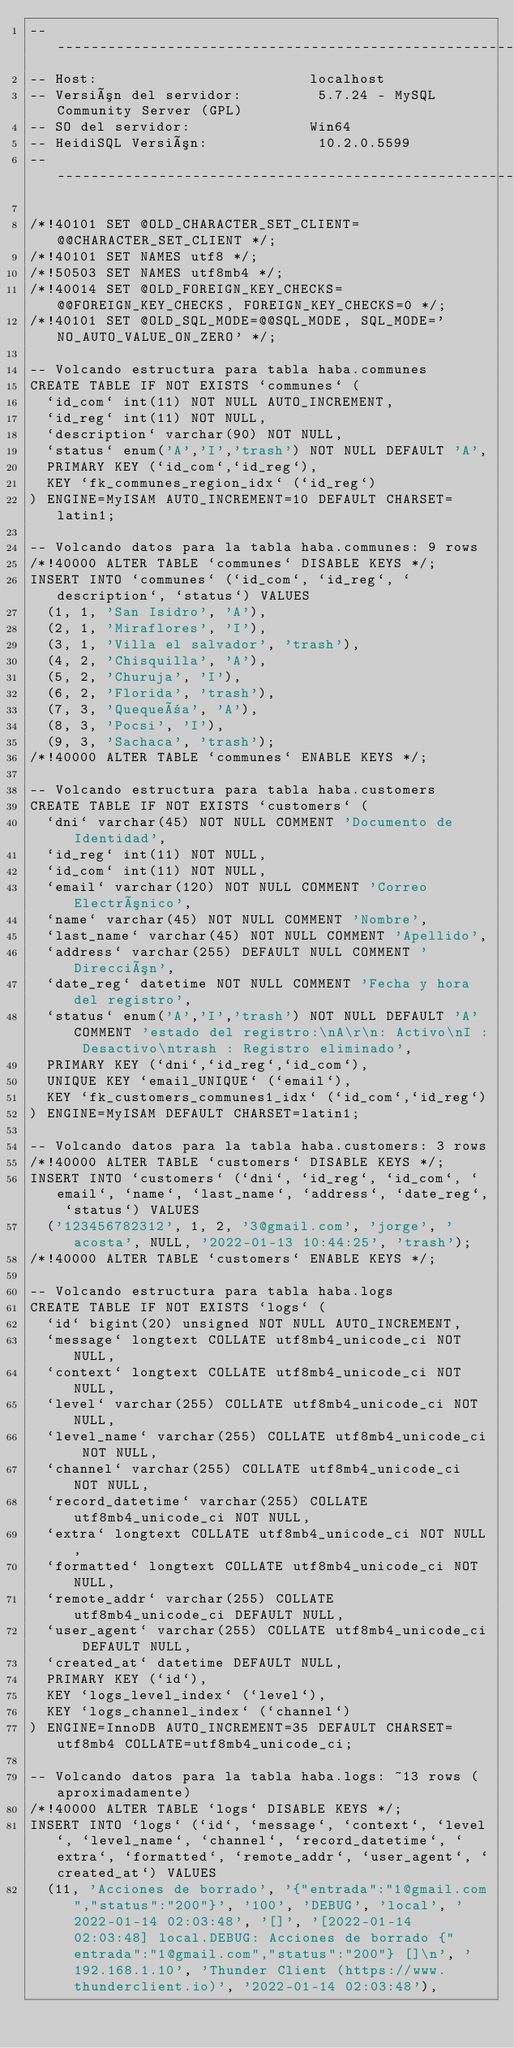Convert code to text. <code><loc_0><loc_0><loc_500><loc_500><_SQL_>-- --------------------------------------------------------
-- Host:                         localhost
-- Versión del servidor:         5.7.24 - MySQL Community Server (GPL)
-- SO del servidor:              Win64
-- HeidiSQL Versión:             10.2.0.5599
-- --------------------------------------------------------

/*!40101 SET @OLD_CHARACTER_SET_CLIENT=@@CHARACTER_SET_CLIENT */;
/*!40101 SET NAMES utf8 */;
/*!50503 SET NAMES utf8mb4 */;
/*!40014 SET @OLD_FOREIGN_KEY_CHECKS=@@FOREIGN_KEY_CHECKS, FOREIGN_KEY_CHECKS=0 */;
/*!40101 SET @OLD_SQL_MODE=@@SQL_MODE, SQL_MODE='NO_AUTO_VALUE_ON_ZERO' */;

-- Volcando estructura para tabla haba.communes
CREATE TABLE IF NOT EXISTS `communes` (
  `id_com` int(11) NOT NULL AUTO_INCREMENT,
  `id_reg` int(11) NOT NULL,
  `description` varchar(90) NOT NULL,
  `status` enum('A','I','trash') NOT NULL DEFAULT 'A',
  PRIMARY KEY (`id_com`,`id_reg`),
  KEY `fk_communes_region_idx` (`id_reg`)
) ENGINE=MyISAM AUTO_INCREMENT=10 DEFAULT CHARSET=latin1;

-- Volcando datos para la tabla haba.communes: 9 rows
/*!40000 ALTER TABLE `communes` DISABLE KEYS */;
INSERT INTO `communes` (`id_com`, `id_reg`, `description`, `status`) VALUES
	(1, 1, 'San Isidro', 'A'),
	(2, 1, 'Miraflores', 'I'),
	(3, 1, 'Villa el salvador', 'trash'),
	(4, 2, 'Chisquilla', 'A'),
	(5, 2, 'Churuja', 'I'),
	(6, 2, 'Florida', 'trash'),
	(7, 3, 'Quequeña', 'A'),
	(8, 3, 'Pocsi', 'I'),
	(9, 3, 'Sachaca', 'trash');
/*!40000 ALTER TABLE `communes` ENABLE KEYS */;

-- Volcando estructura para tabla haba.customers
CREATE TABLE IF NOT EXISTS `customers` (
  `dni` varchar(45) NOT NULL COMMENT 'Documento de Identidad',
  `id_reg` int(11) NOT NULL,
  `id_com` int(11) NOT NULL,
  `email` varchar(120) NOT NULL COMMENT 'Correo Electrónico',
  `name` varchar(45) NOT NULL COMMENT 'Nombre',
  `last_name` varchar(45) NOT NULL COMMENT 'Apellido',
  `address` varchar(255) DEFAULT NULL COMMENT 'Dirección',
  `date_reg` datetime NOT NULL COMMENT 'Fecha y hora del registro',
  `status` enum('A','I','trash') NOT NULL DEFAULT 'A' COMMENT 'estado del registro:\nA\r\n: Activo\nI : Desactivo\ntrash : Registro eliminado',
  PRIMARY KEY (`dni`,`id_reg`,`id_com`),
  UNIQUE KEY `email_UNIQUE` (`email`),
  KEY `fk_customers_communes1_idx` (`id_com`,`id_reg`)
) ENGINE=MyISAM DEFAULT CHARSET=latin1;

-- Volcando datos para la tabla haba.customers: 3 rows
/*!40000 ALTER TABLE `customers` DISABLE KEYS */;
INSERT INTO `customers` (`dni`, `id_reg`, `id_com`, `email`, `name`, `last_name`, `address`, `date_reg`, `status`) VALUES
	('123456782312', 1, 2, '3@gmail.com', 'jorge', 'acosta', NULL, '2022-01-13 10:44:25', 'trash');
/*!40000 ALTER TABLE `customers` ENABLE KEYS */;

-- Volcando estructura para tabla haba.logs
CREATE TABLE IF NOT EXISTS `logs` (
  `id` bigint(20) unsigned NOT NULL AUTO_INCREMENT,
  `message` longtext COLLATE utf8mb4_unicode_ci NOT NULL,
  `context` longtext COLLATE utf8mb4_unicode_ci NOT NULL,
  `level` varchar(255) COLLATE utf8mb4_unicode_ci NOT NULL,
  `level_name` varchar(255) COLLATE utf8mb4_unicode_ci NOT NULL,
  `channel` varchar(255) COLLATE utf8mb4_unicode_ci NOT NULL,
  `record_datetime` varchar(255) COLLATE utf8mb4_unicode_ci NOT NULL,
  `extra` longtext COLLATE utf8mb4_unicode_ci NOT NULL,
  `formatted` longtext COLLATE utf8mb4_unicode_ci NOT NULL,
  `remote_addr` varchar(255) COLLATE utf8mb4_unicode_ci DEFAULT NULL,
  `user_agent` varchar(255) COLLATE utf8mb4_unicode_ci DEFAULT NULL,
  `created_at` datetime DEFAULT NULL,
  PRIMARY KEY (`id`),
  KEY `logs_level_index` (`level`),
  KEY `logs_channel_index` (`channel`)
) ENGINE=InnoDB AUTO_INCREMENT=35 DEFAULT CHARSET=utf8mb4 COLLATE=utf8mb4_unicode_ci;

-- Volcando datos para la tabla haba.logs: ~13 rows (aproximadamente)
/*!40000 ALTER TABLE `logs` DISABLE KEYS */;
INSERT INTO `logs` (`id`, `message`, `context`, `level`, `level_name`, `channel`, `record_datetime`, `extra`, `formatted`, `remote_addr`, `user_agent`, `created_at`) VALUES
	(11, 'Acciones de borrado', '{"entrada":"1@gmail.com","status":"200"}', '100', 'DEBUG', 'local', '2022-01-14 02:03:48', '[]', '[2022-01-14 02:03:48] local.DEBUG: Acciones de borrado {"entrada":"1@gmail.com","status":"200"} []\n', '192.168.1.10', 'Thunder Client (https://www.thunderclient.io)', '2022-01-14 02:03:48'),</code> 